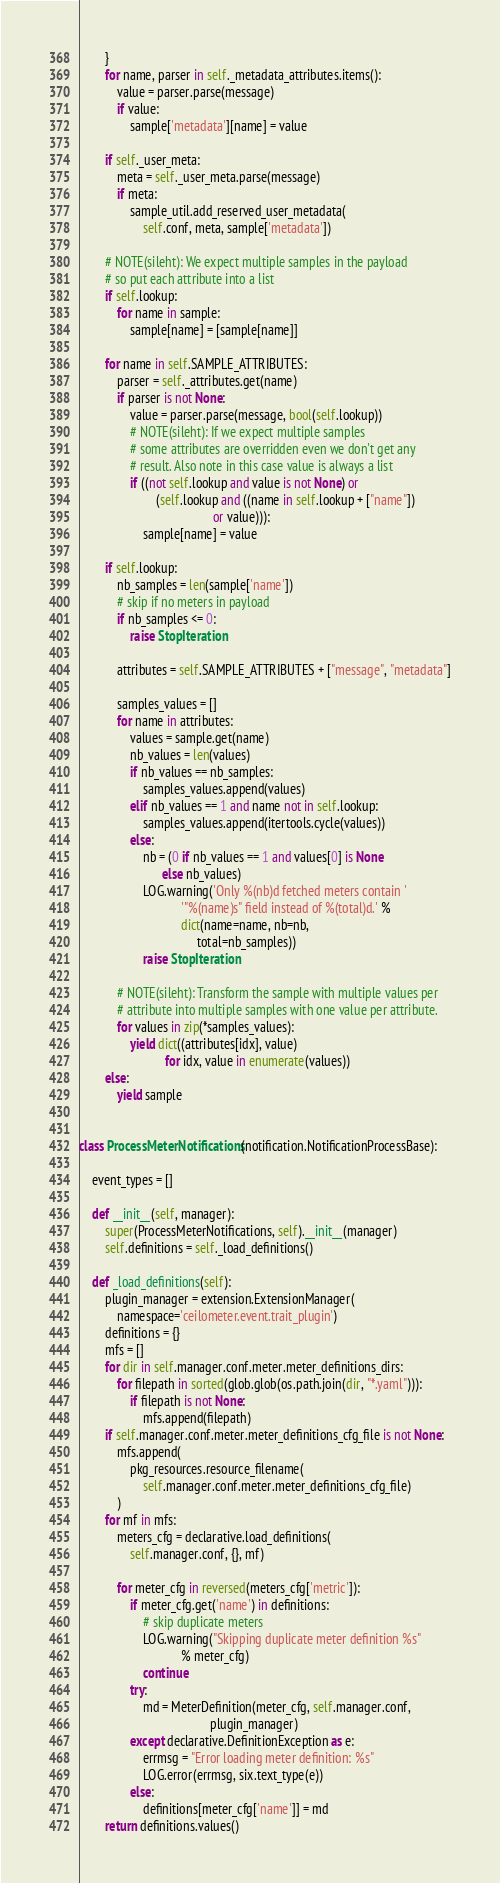<code> <loc_0><loc_0><loc_500><loc_500><_Python_>        }
        for name, parser in self._metadata_attributes.items():
            value = parser.parse(message)
            if value:
                sample['metadata'][name] = value

        if self._user_meta:
            meta = self._user_meta.parse(message)
            if meta:
                sample_util.add_reserved_user_metadata(
                    self.conf, meta, sample['metadata'])

        # NOTE(sileht): We expect multiple samples in the payload
        # so put each attribute into a list
        if self.lookup:
            for name in sample:
                sample[name] = [sample[name]]

        for name in self.SAMPLE_ATTRIBUTES:
            parser = self._attributes.get(name)
            if parser is not None:
                value = parser.parse(message, bool(self.lookup))
                # NOTE(sileht): If we expect multiple samples
                # some attributes are overridden even we don't get any
                # result. Also note in this case value is always a list
                if ((not self.lookup and value is not None) or
                        (self.lookup and ((name in self.lookup + ["name"])
                                          or value))):
                    sample[name] = value

        if self.lookup:
            nb_samples = len(sample['name'])
            # skip if no meters in payload
            if nb_samples <= 0:
                raise StopIteration

            attributes = self.SAMPLE_ATTRIBUTES + ["message", "metadata"]

            samples_values = []
            for name in attributes:
                values = sample.get(name)
                nb_values = len(values)
                if nb_values == nb_samples:
                    samples_values.append(values)
                elif nb_values == 1 and name not in self.lookup:
                    samples_values.append(itertools.cycle(values))
                else:
                    nb = (0 if nb_values == 1 and values[0] is None
                          else nb_values)
                    LOG.warning('Only %(nb)d fetched meters contain '
                                '"%(name)s" field instead of %(total)d.' %
                                dict(name=name, nb=nb,
                                     total=nb_samples))
                    raise StopIteration

            # NOTE(sileht): Transform the sample with multiple values per
            # attribute into multiple samples with one value per attribute.
            for values in zip(*samples_values):
                yield dict((attributes[idx], value)
                           for idx, value in enumerate(values))
        else:
            yield sample


class ProcessMeterNotifications(notification.NotificationProcessBase):

    event_types = []

    def __init__(self, manager):
        super(ProcessMeterNotifications, self).__init__(manager)
        self.definitions = self._load_definitions()

    def _load_definitions(self):
        plugin_manager = extension.ExtensionManager(
            namespace='ceilometer.event.trait_plugin')
        definitions = {}
        mfs = []
        for dir in self.manager.conf.meter.meter_definitions_dirs:
            for filepath in sorted(glob.glob(os.path.join(dir, "*.yaml"))):
                if filepath is not None:
                    mfs.append(filepath)
        if self.manager.conf.meter.meter_definitions_cfg_file is not None:
            mfs.append(
                pkg_resources.resource_filename(
                    self.manager.conf.meter.meter_definitions_cfg_file)
            )
        for mf in mfs:
            meters_cfg = declarative.load_definitions(
                self.manager.conf, {}, mf)

            for meter_cfg in reversed(meters_cfg['metric']):
                if meter_cfg.get('name') in definitions:
                    # skip duplicate meters
                    LOG.warning("Skipping duplicate meter definition %s"
                                % meter_cfg)
                    continue
                try:
                    md = MeterDefinition(meter_cfg, self.manager.conf,
                                         plugin_manager)
                except declarative.DefinitionException as e:
                    errmsg = "Error loading meter definition: %s"
                    LOG.error(errmsg, six.text_type(e))
                else:
                    definitions[meter_cfg['name']] = md
        return definitions.values()
</code> 